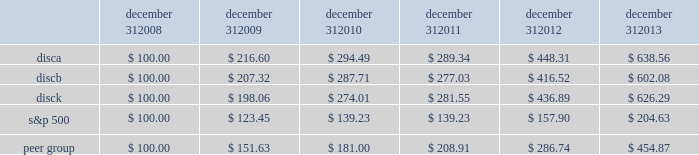Common stock from time to time through open market purchases or privately negotiated transactions at prevailing prices as permitted by securities laws and other legal requirements , and subject to stock price , business and market conditions and other factors .
We have been funding and expect to continue to fund stock repurchases through a combination of cash on hand and cash generated by operations .
In the future , we may also choose to fund our stock repurchase program under our revolving credit facility or future financing transactions .
There were no repurchases of our series a and b common stock during the three months ended december 31 , 2013 .
The company first announced its stock repurchase program on august 3 , 2010 .
Stock performance graph the following graph sets forth the cumulative total shareholder return on our series a common stock , series b common stock and series c common stock as compared with the cumulative total return of the companies listed in the standard and poor 2019s 500 stock index ( 201cs&p 500 index 201d ) and a peer group of companies comprised of cbs corporation class b common stock , scripps network interactive , inc. , time warner , inc. , twenty-first century fox , inc .
Class a common stock ( news corporation class a common stock prior to june 2013 ) , viacom , inc .
Class b common stock and the walt disney company .
The graph assumes $ 100 originally invested on december 31 , 2008 in each of our series a common stock , series b common stock and series c common stock , the s&p 500 index , and the stock of our peer group companies , including reinvestment of dividends , for the years ended december 31 , 2009 , 2010 , 2011 , 2012 and 2013 .
December 31 , december 31 , december 31 , december 31 , december 31 , december 31 .
Equity compensation plan information information regarding securities authorized for issuance under equity compensation plans will be set forth in our definitive proxy statement for our 2014 annual meeting of stockholders under the caption 201csecurities authorized for issuance under equity compensation plans , 201d which is incorporated herein by reference. .
What was the five year average uncompounded annual return for the s&p 500? 
Computations: ((204.63 - 100) / (2013 - 2008))
Answer: 20.926. 